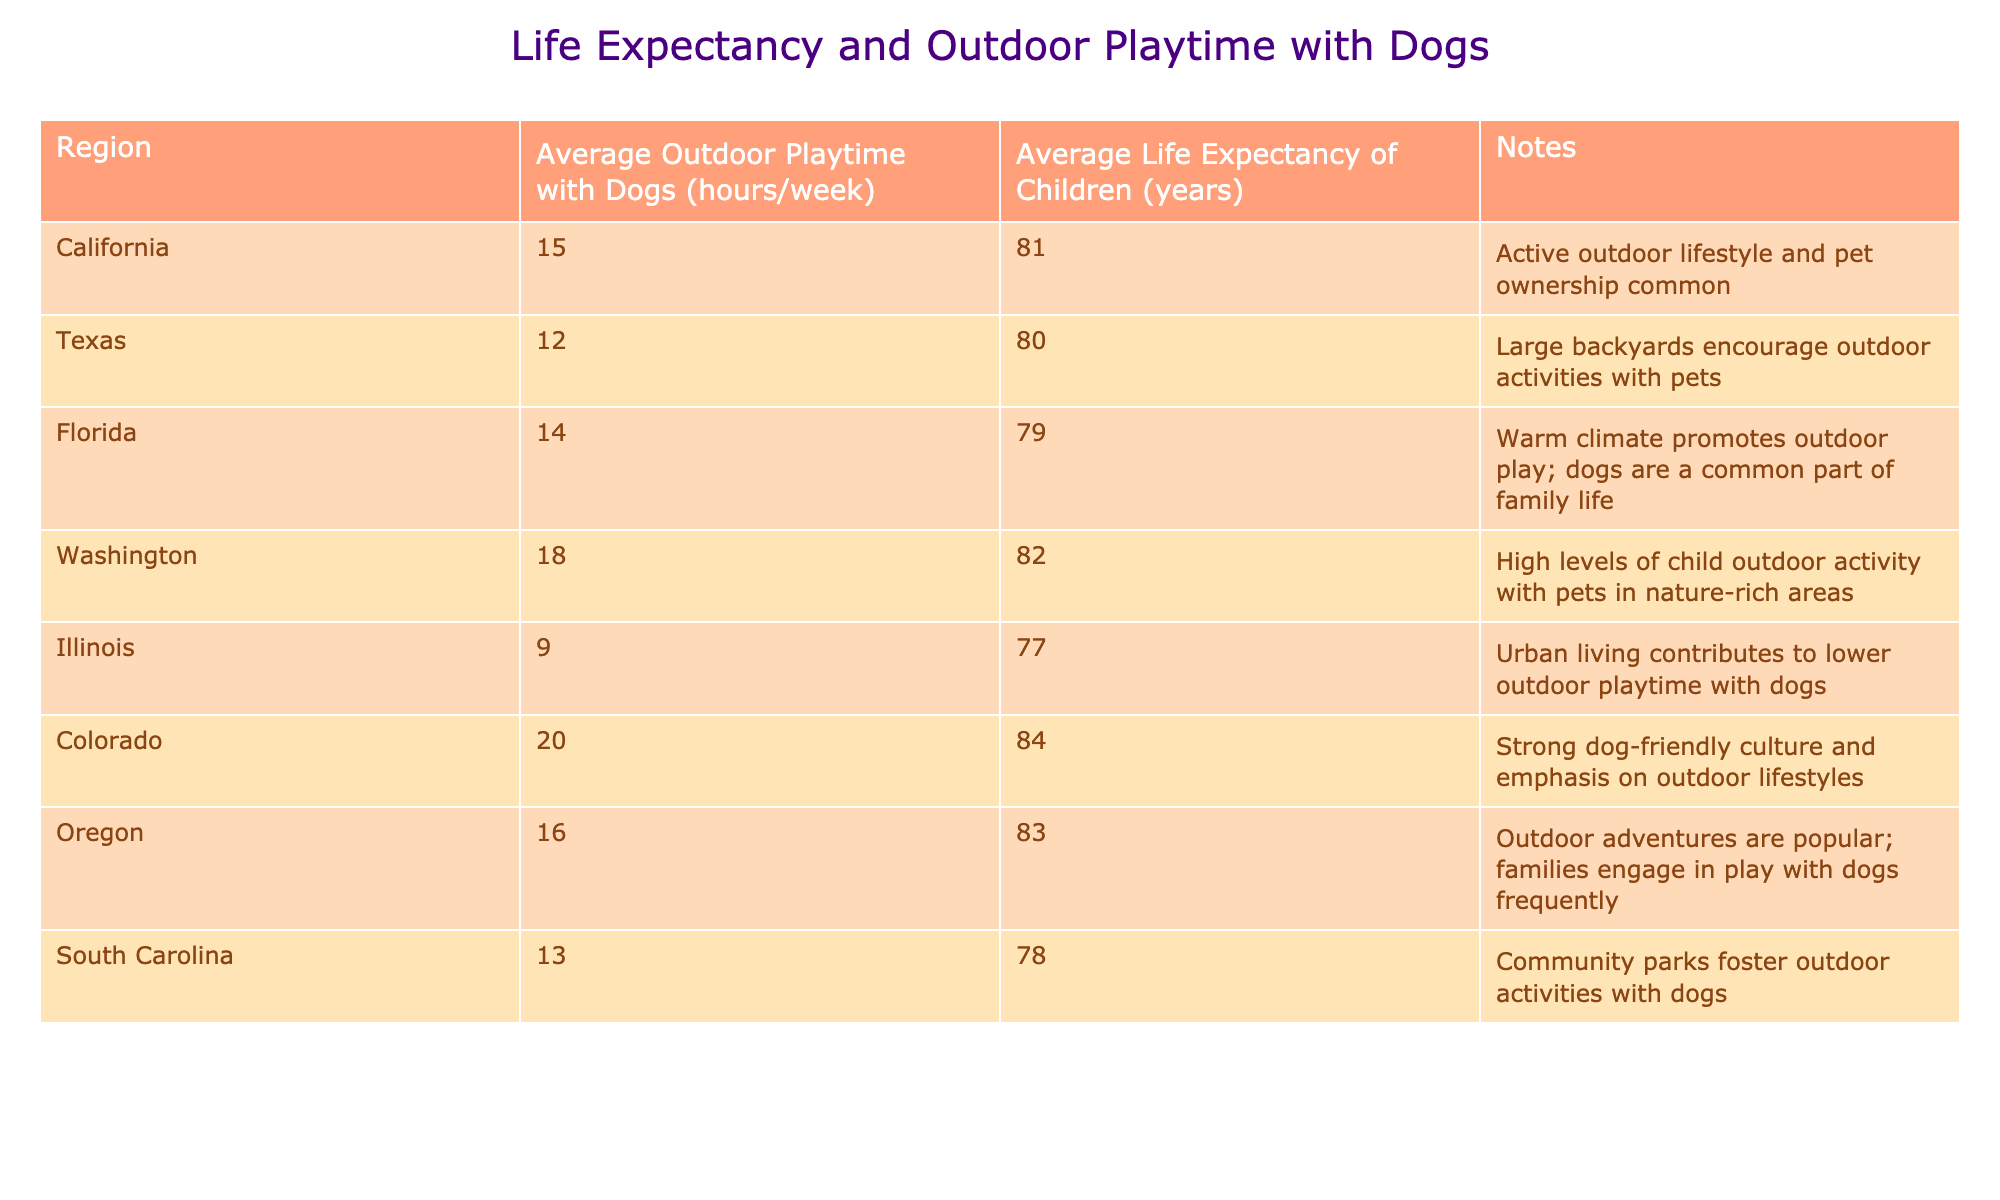What is the average life expectancy of children in California? The table shows that the average life expectancy of children in California is listed as 81 years.
Answer: 81 Which region has the highest average outdoor playtime with dogs? According to the table, Colorado has the highest average outdoor playtime with dogs, which is 20 hours per week.
Answer: 20 Do children in Florida have a higher life expectancy than those in Texas? The average life expectancy in Florida is 79 years, while in Texas it is 80 years; therefore, children in Florida do not have a higher life expectancy than those in Texas.
Answer: No What is the difference in average life expectancy between Colorado and Illinois? Colorado has an average life expectancy of 84 years, and Illinois has an average life expectancy of 77 years. The difference is 84 - 77 = 7 years.
Answer: 7 What is the average outdoor playtime with dogs for the regions that have a life expectancy above 80 years? The regions with life expectancy above 80 years are California (15), Washington (18), Colorado (20), and Oregon (16). The average for these is (15 + 18 + 20 + 16) / 4 = 17.25 hours per week.
Answer: 17.25 Is there a correlation between outdoor playtime with dogs and life expectancy? Observing the table, regions with higher outdoor playtime with dogs, such as Colorado, also have higher life expectancies, suggesting a possible positive correlation.
Answer: Yes Which states have an average outdoor playtime with dogs less than 10 hours per week? Peering into the table reveals that Illinois is the only state with an average outdoor playtime with dogs of 9 hours per week.
Answer: Illinois If Washington increased its average outdoor playtime with dogs to 20 hours, what would be its new average life expectancy? The table does not provide a formal relationship or model to predict life expectancy based solely on outdoor playtime; thus, it is not possible to calculate a new life expectancy figure for Washington if outdoor playtime increased.
Answer: Not applicable What is the total sum of average outdoor playtime with dogs across all regions? Adding the values: 15 + 12 + 14 + 18 + 9 + 20 + 16 + 13 = 117 hours per week.
Answer: 117 